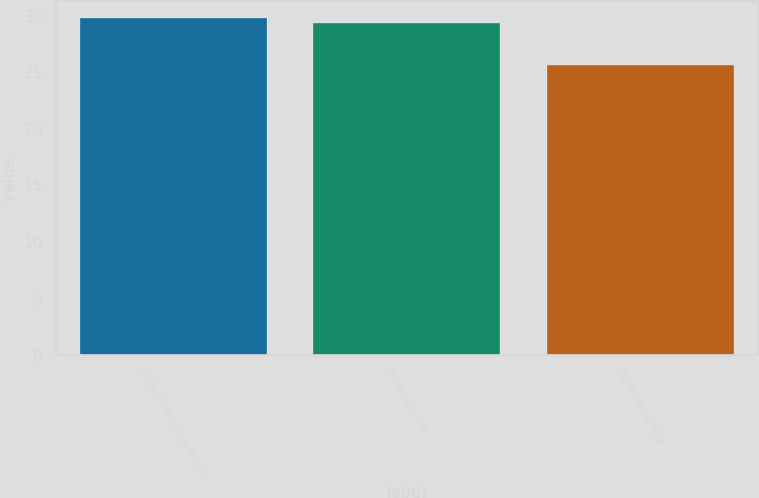<chart> <loc_0><loc_0><loc_500><loc_500><bar_chart><fcel>Outstanding at December 31<fcel>Expected to vest<fcel>Options exercisable<nl><fcel>29.79<fcel>29.37<fcel>25.65<nl></chart> 